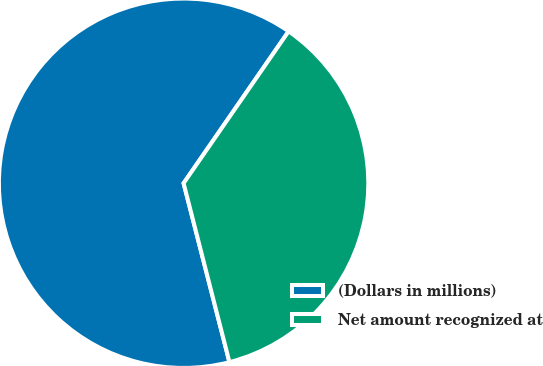Convert chart. <chart><loc_0><loc_0><loc_500><loc_500><pie_chart><fcel>(Dollars in millions)<fcel>Net amount recognized at<nl><fcel>63.62%<fcel>36.38%<nl></chart> 